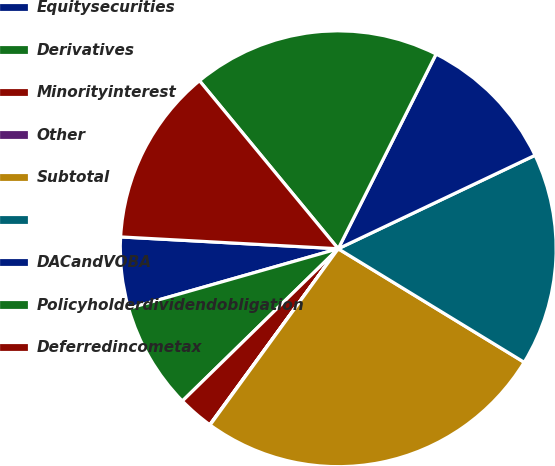Convert chart. <chart><loc_0><loc_0><loc_500><loc_500><pie_chart><fcel>Equitysecurities<fcel>Derivatives<fcel>Minorityinterest<fcel>Other<fcel>Subtotal<fcel>Unnamed: 5<fcel>DACandVOBA<fcel>Policyholderdividendobligation<fcel>Deferredincometax<nl><fcel>5.28%<fcel>7.9%<fcel>2.65%<fcel>0.03%<fcel>26.28%<fcel>15.78%<fcel>10.53%<fcel>18.4%<fcel>13.15%<nl></chart> 